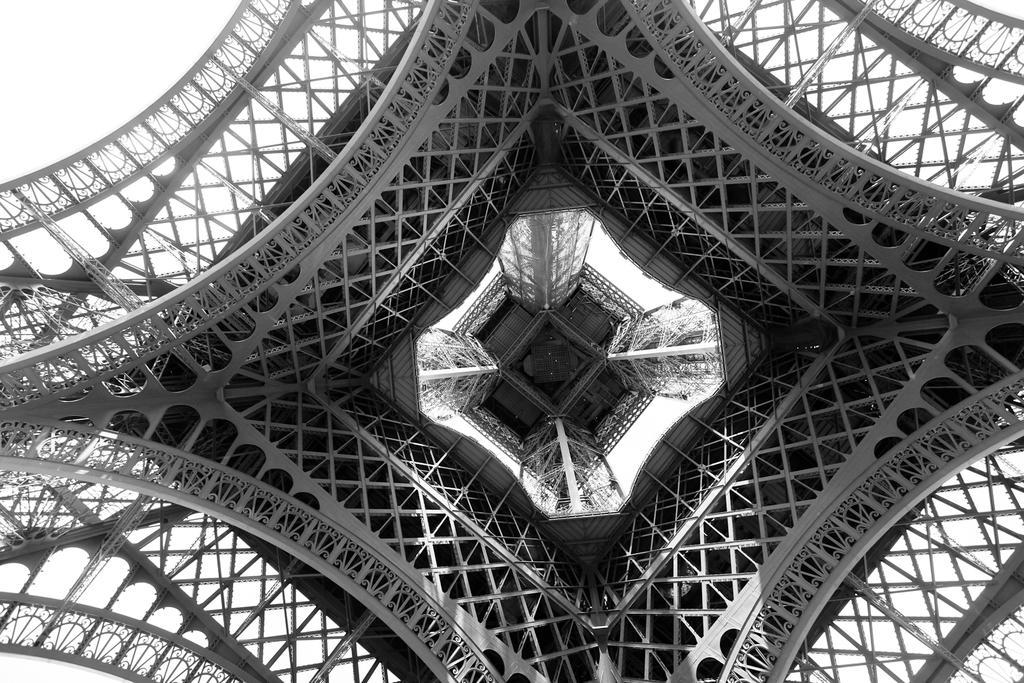Please provide a concise description of this image. In this black and white picture there is a tower. This picture is clicked from under the tower. The background is white. 